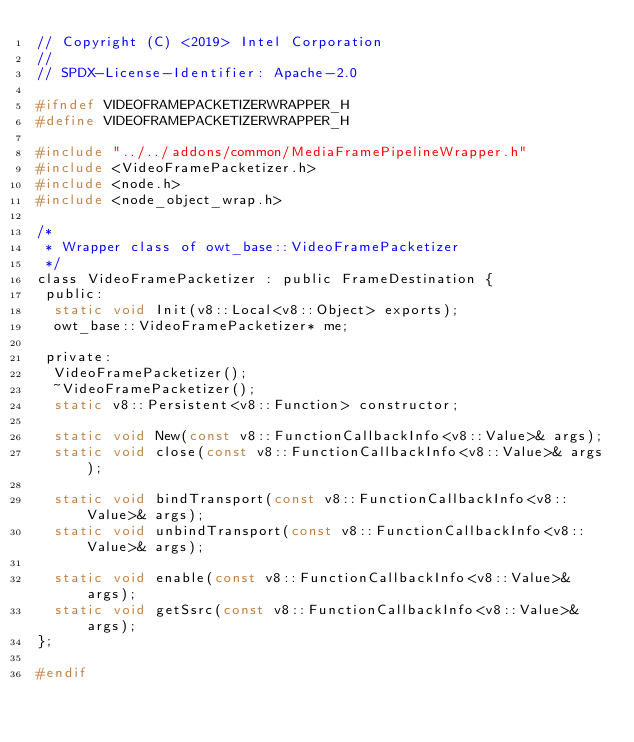<code> <loc_0><loc_0><loc_500><loc_500><_C_>// Copyright (C) <2019> Intel Corporation
//
// SPDX-License-Identifier: Apache-2.0

#ifndef VIDEOFRAMEPACKETIZERWRAPPER_H
#define VIDEOFRAMEPACKETIZERWRAPPER_H

#include "../../addons/common/MediaFramePipelineWrapper.h"
#include <VideoFramePacketizer.h>
#include <node.h>
#include <node_object_wrap.h>

/*
 * Wrapper class of owt_base::VideoFramePacketizer
 */
class VideoFramePacketizer : public FrameDestination {
 public:
  static void Init(v8::Local<v8::Object> exports);
  owt_base::VideoFramePacketizer* me;

 private:
  VideoFramePacketizer();
  ~VideoFramePacketizer();
  static v8::Persistent<v8::Function> constructor;

  static void New(const v8::FunctionCallbackInfo<v8::Value>& args);
  static void close(const v8::FunctionCallbackInfo<v8::Value>& args);

  static void bindTransport(const v8::FunctionCallbackInfo<v8::Value>& args);
  static void unbindTransport(const v8::FunctionCallbackInfo<v8::Value>& args);

  static void enable(const v8::FunctionCallbackInfo<v8::Value>& args);
  static void getSsrc(const v8::FunctionCallbackInfo<v8::Value>& args);
};

#endif
</code> 